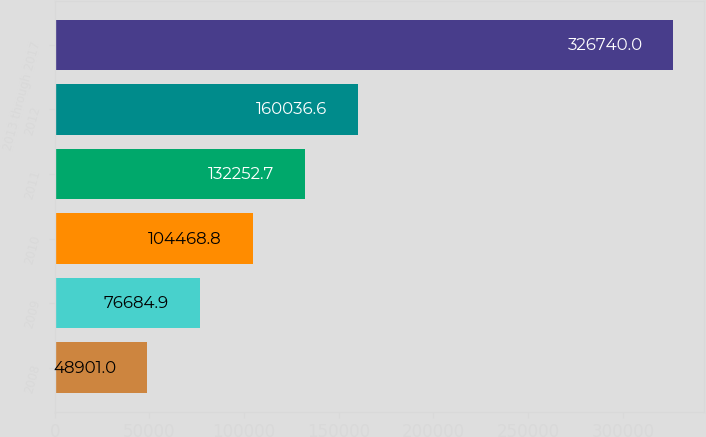Convert chart to OTSL. <chart><loc_0><loc_0><loc_500><loc_500><bar_chart><fcel>2008<fcel>2009<fcel>2010<fcel>2011<fcel>2012<fcel>2013 through 2017<nl><fcel>48901<fcel>76684.9<fcel>104469<fcel>132253<fcel>160037<fcel>326740<nl></chart> 